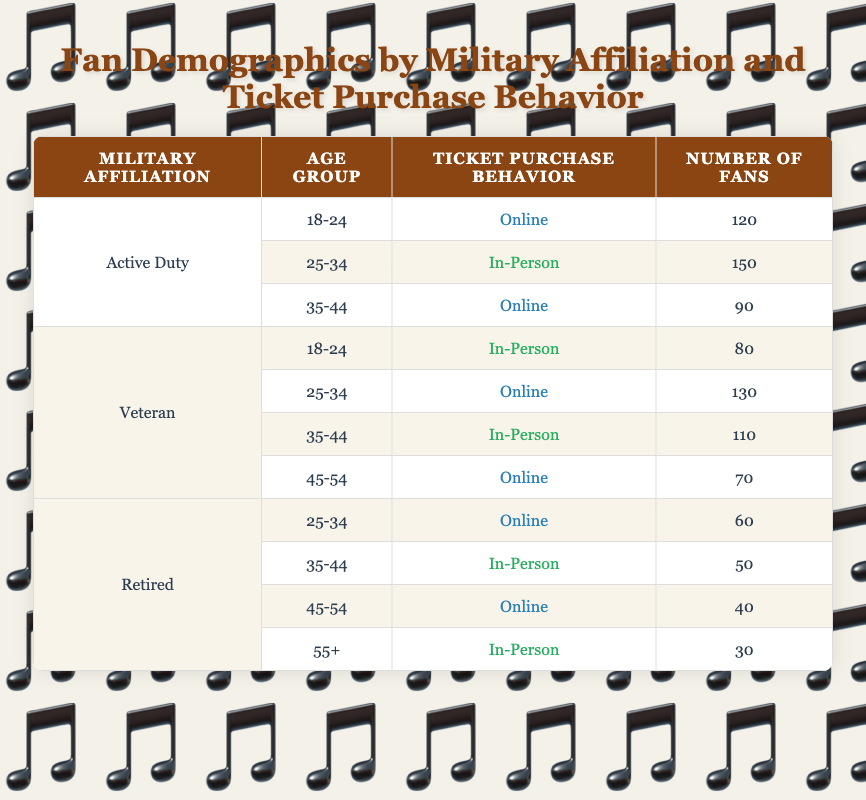What is the number of Active Duty fans who purchase tickets online? The table shows 120 fans in the 18-24 age group and 90 fans in the 35-44 age group who purchase tickets online under the Active Duty category. Thus, we add these two values: 120 + 90 = 210.
Answer: 210 Which military affiliation has the highest number of in-person ticket purchases? We need to look for the highest number in the "In-Person" category across the military affiliations. The Active Duty for 25-34 has 150 fans, Veterans for both age groups 18-24 and 35-44 have 80 and 110, and Retired has 50 and 30. The maximum is 150 from Active Duty.
Answer: Active Duty Is the statement "Veterans aged 25-34 prefer online ticket purchases" true or false? The table indicates that 130 Veterans in the 25-34 age group purchase tickets online. Therefore, the statement is true as it accurately reflects the data.
Answer: True How many fans are in the age group of 35-44 for all military affiliations combined? We find each military affiliation's total in the 35-44 age group from the table: Active Duty has 90, Veterans have 110, and Retired have 50. Adding them gives: 90 + 110 + 50 = 250.
Answer: 250 What is the total number of fans who purchase tickets in-person? To find this total, we summarize the in-person ticket purchases: Active Duty 25-34 has 150, Veterans for 18-24 has 80, 35-44 has 110, and Retired for 35-44 has 50, plus 55+ has 30. Therefore, we calculate: 150 + 80 + 110 + 50 + 30 = 420.
Answer: 420 Which age group for Retired fans has the least number of in-person ticket purchases? Analyzing the Retired fans' entries, we see that in-person ticket purchases are least for the 55+ age group with 30 fans.
Answer: 55+ Are there more Active Duty fans aged 18-24 who purchase tickets online than Retired fans aged 45-54 who do the same? The table lists 120 Active Duty fans aged 18-24 purchasing online, while Retired fans aged 45-54 buying online amounts to 40. Since 120 is greater than 40, the answer is yes.
Answer: Yes How many more online ticket purchasers are Veterans aged 25-34 than Retired aged 25-34? From the table, Veterans aged 25-34 have 130 online ticket purchasers while Retired aged 25-34 have 60. The difference is calculated as 130 - 60 = 70.
Answer: 70 